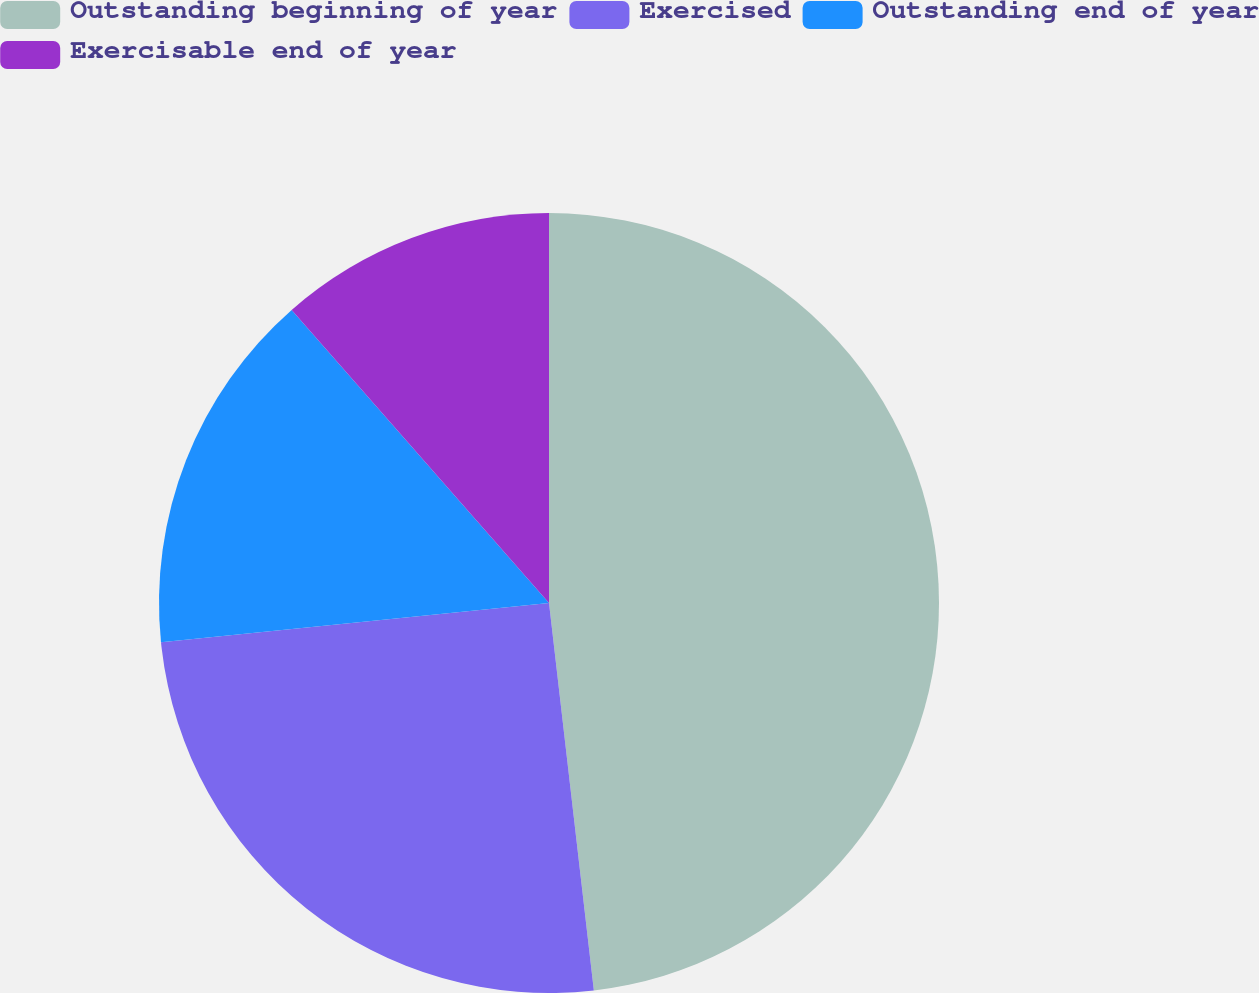Convert chart. <chart><loc_0><loc_0><loc_500><loc_500><pie_chart><fcel>Outstanding beginning of year<fcel>Exercised<fcel>Outstanding end of year<fcel>Exercisable end of year<nl><fcel>48.17%<fcel>25.23%<fcel>15.14%<fcel>11.47%<nl></chart> 